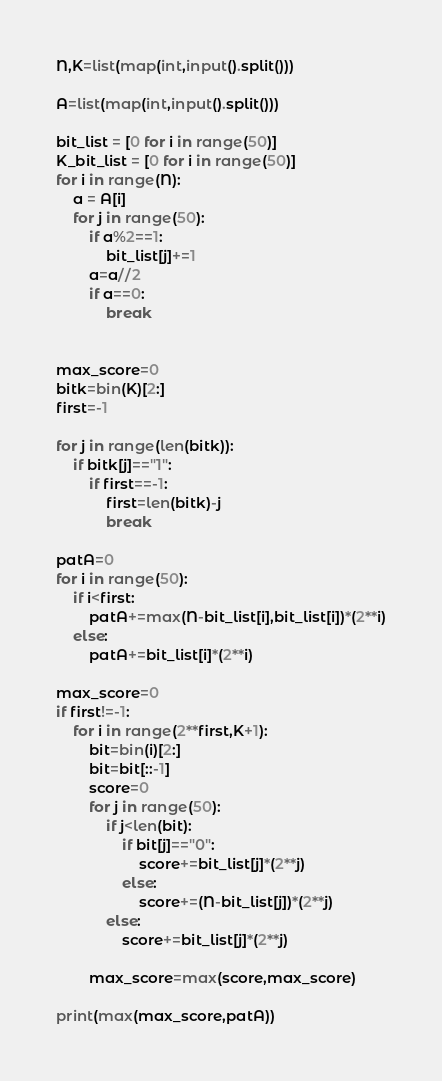<code> <loc_0><loc_0><loc_500><loc_500><_Python_>N,K=list(map(int,input().split()))

A=list(map(int,input().split()))

bit_list = [0 for i in range(50)]
K_bit_list = [0 for i in range(50)]
for i in range(N):
    a = A[i]
    for j in range(50):
        if a%2==1:
            bit_list[j]+=1
        a=a//2
        if a==0:
            break


max_score=0
bitk=bin(K)[2:]
first=-1

for j in range(len(bitk)):
    if bitk[j]=="1":
        if first==-1:
            first=len(bitk)-j
            break

patA=0
for i in range(50):
    if i<first:
        patA+=max(N-bit_list[i],bit_list[i])*(2**i)
    else:
        patA+=bit_list[i]*(2**i)

max_score=0
if first!=-1:
    for i in range(2**first,K+1):
        bit=bin(i)[2:]
        bit=bit[::-1]
        score=0
        for j in range(50):
            if j<len(bit):
                if bit[j]=="0":
                    score+=bit_list[j]*(2**j)
                else:
                    score+=(N-bit_list[j])*(2**j)
            else:
                score+=bit_list[j]*(2**j)
                
        max_score=max(score,max_score)    
    
print(max(max_score,patA))</code> 